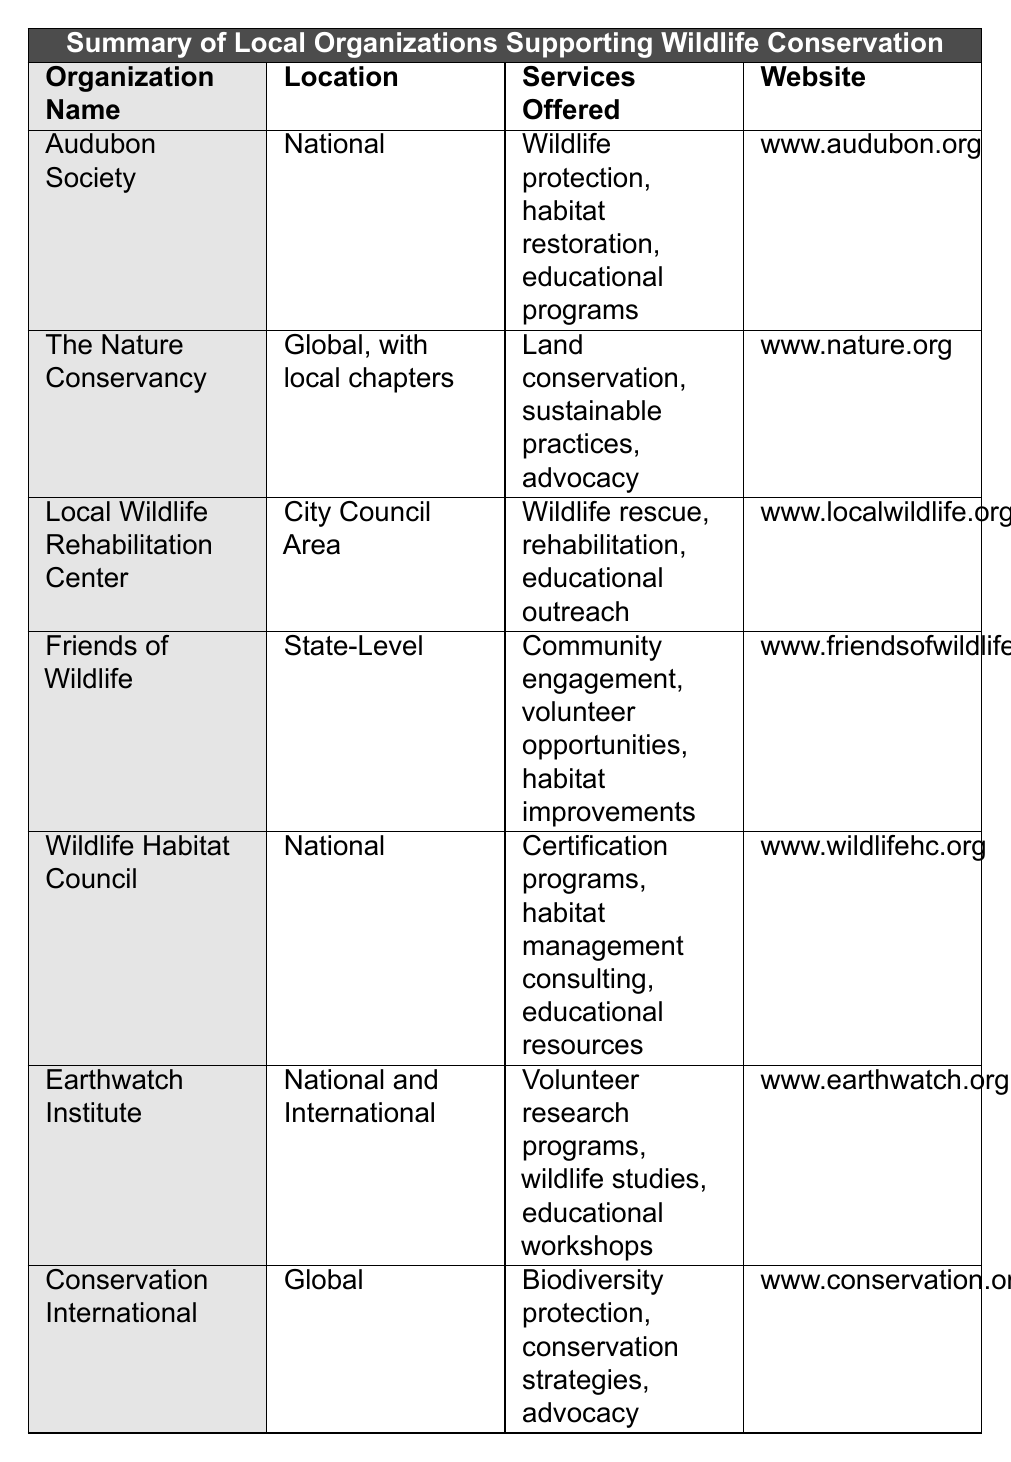What services does the Audubon Society offer? The table lists the services offered by each organization. For the Audubon Society, the services include wildlife protection, habitat restoration, and educational programs.
Answer: Wildlife protection, habitat restoration, educational programs How many organizations provide services at a national level? The organizations specified to provide national-level services are Audubon Society, Wildlife Habitat Council, and Earthwatch Institute. Counting these gives us three organizations.
Answer: 3 Does the Local Wildlife Rehabilitation Center operate globally? The table shows that the Local Wildlife Rehabilitation Center's location is given as "City Council Area," which indicates that it operates locally, not globally. Therefore, the answer is false.
Answer: No Which organization offers volunteer research programs? Referring to the services offered, the Earthwatch Institute offers volunteer research programs, along with wildlife studies and educational workshops.
Answer: Earthwatch Institute What is the difference in the number of services offered by the Nature Conservancy and Friends of Wildlife? The Nature Conservancy offers three services: land conservation, sustainable practices, and advocacy. Friends of Wildlife offers three services as well: community engagement, volunteer opportunities, and habitat improvements. Since both have the same number of services, the difference is zero.
Answer: 0 Is there any organization that focuses solely on habitat improvements? By reviewing the services offered, Friends of Wildlife mentions habitat improvements, but it also includes other services such as community engagement and volunteer opportunities. Therefore, no organization focuses solely on habitat improvements.
Answer: No What is the relationship between the location of the Earthwatch Institute and the services it offers? The Earthwatch Institute is listed as operating at both national and international levels, and it offers volunteer research programs, wildlife studies, and educational workshops, indicating a broad reach in its mission to involve people in conservation. Thus, its services align with its global and national presence.
Answer: Broad reach aligns with services Which organization has the most comprehensive services based on the provided data? Assessing the services provided, the Nature Conservancy and the Earthwatch Institute offer a range of services including advocacy and educational workshops, suggesting they may have comprehensive services. However, a direct comparison could depend on specific criteria of "comprehensive."
Answer: Nature Conservancy or Earthwatch Institute What website can you visit to learn more about the Wildlife Habitat Council? The table provides a website link for the Wildlife Habitat Council, which is www.wildlifehc.org.
Answer: www.wildlifehc.org 